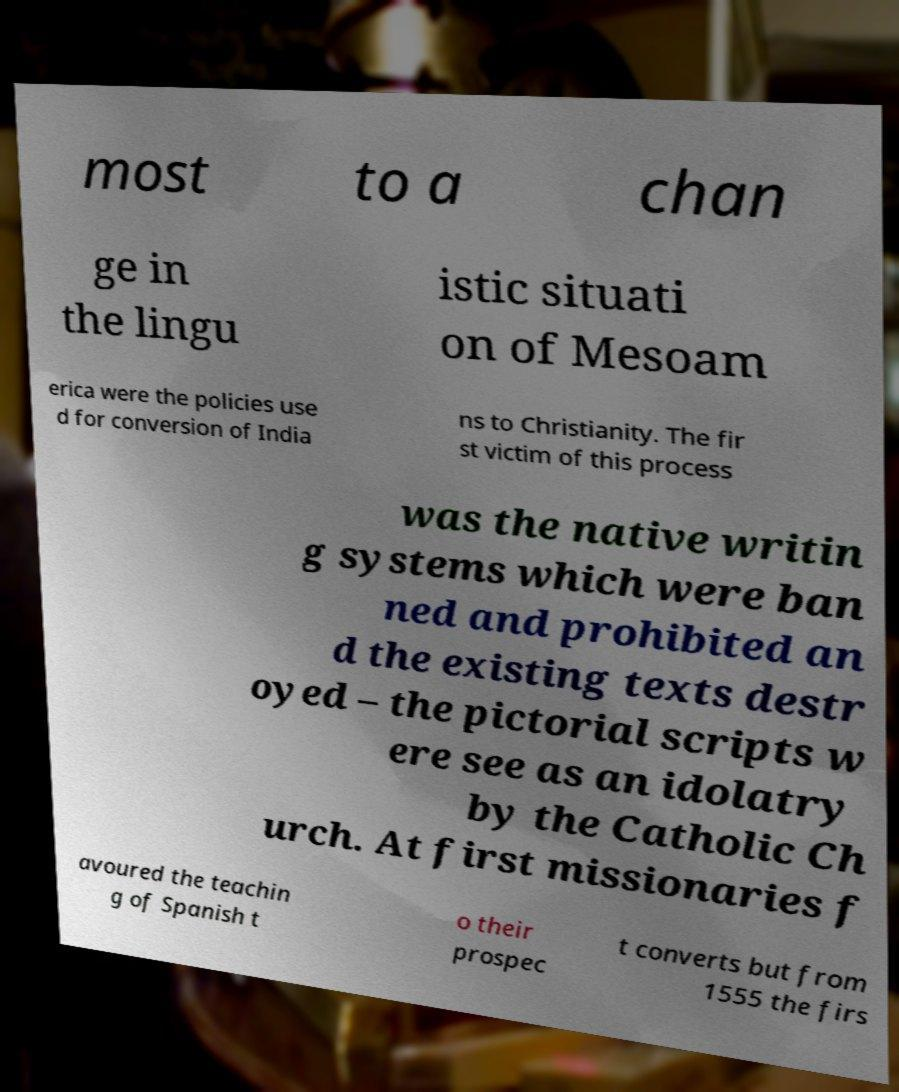There's text embedded in this image that I need extracted. Can you transcribe it verbatim? most to a chan ge in the lingu istic situati on of Mesoam erica were the policies use d for conversion of India ns to Christianity. The fir st victim of this process was the native writin g systems which were ban ned and prohibited an d the existing texts destr oyed – the pictorial scripts w ere see as an idolatry by the Catholic Ch urch. At first missionaries f avoured the teachin g of Spanish t o their prospec t converts but from 1555 the firs 